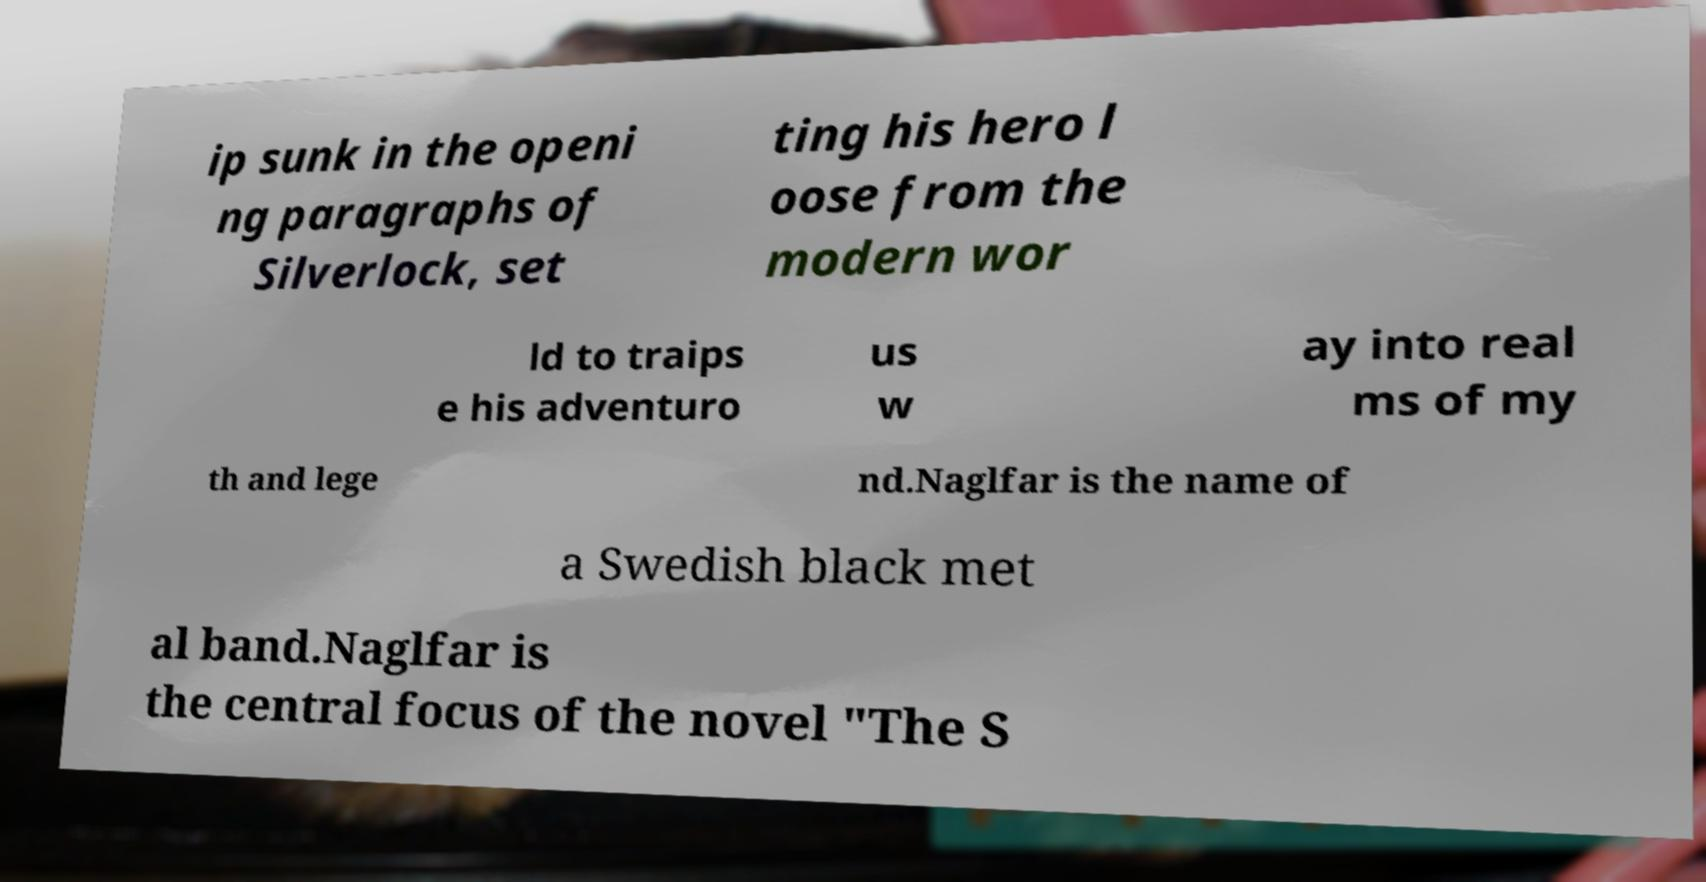Could you assist in decoding the text presented in this image and type it out clearly? ip sunk in the openi ng paragraphs of Silverlock, set ting his hero l oose from the modern wor ld to traips e his adventuro us w ay into real ms of my th and lege nd.Naglfar is the name of a Swedish black met al band.Naglfar is the central focus of the novel "The S 